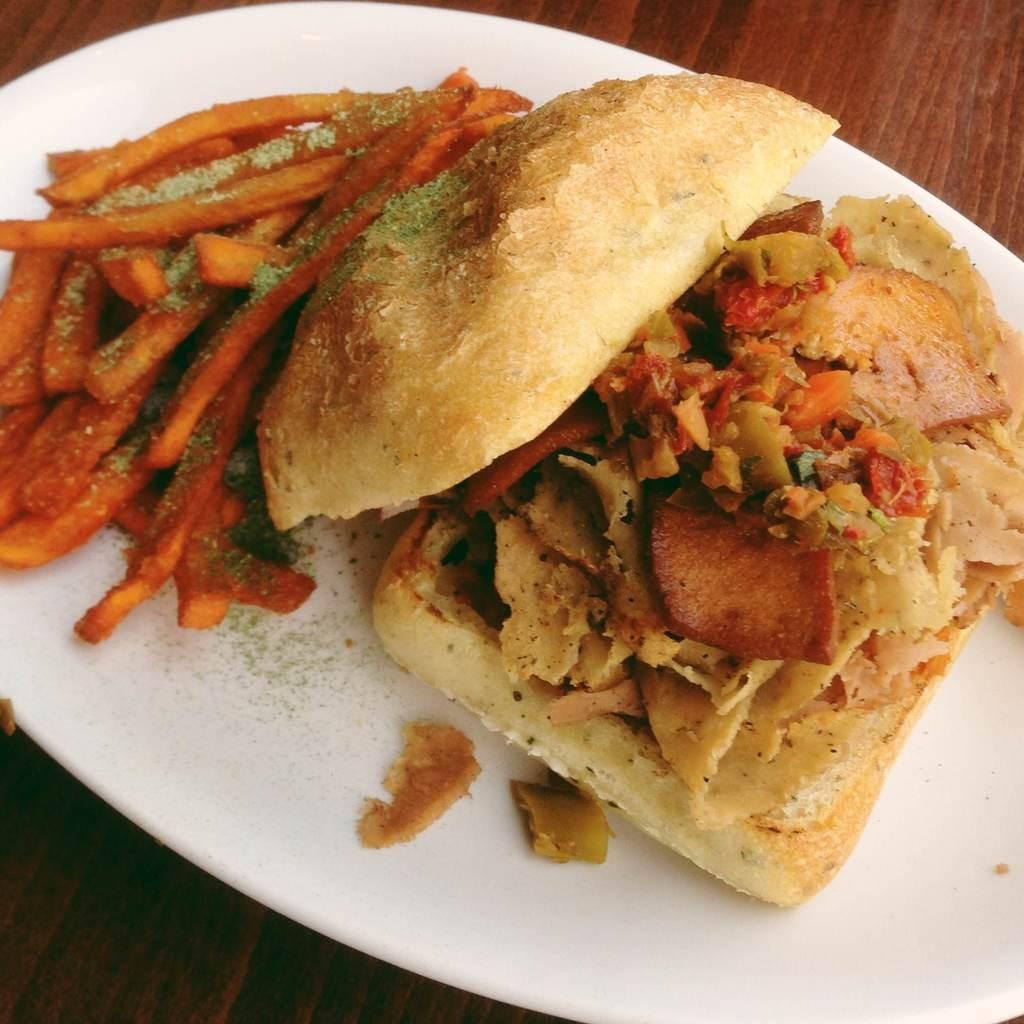What is the main object in the center of the image? There is a plate in the center of the image. What food items are on the plate? The plate contains french fries and a burger. What type of surface is the plate resting on? There is a wooden table at the bottom of the image. What type of business operation is being conducted in the image? There is no indication of a business operation in the image; it simply shows a plate with french fries and a burger on a wooden table. 